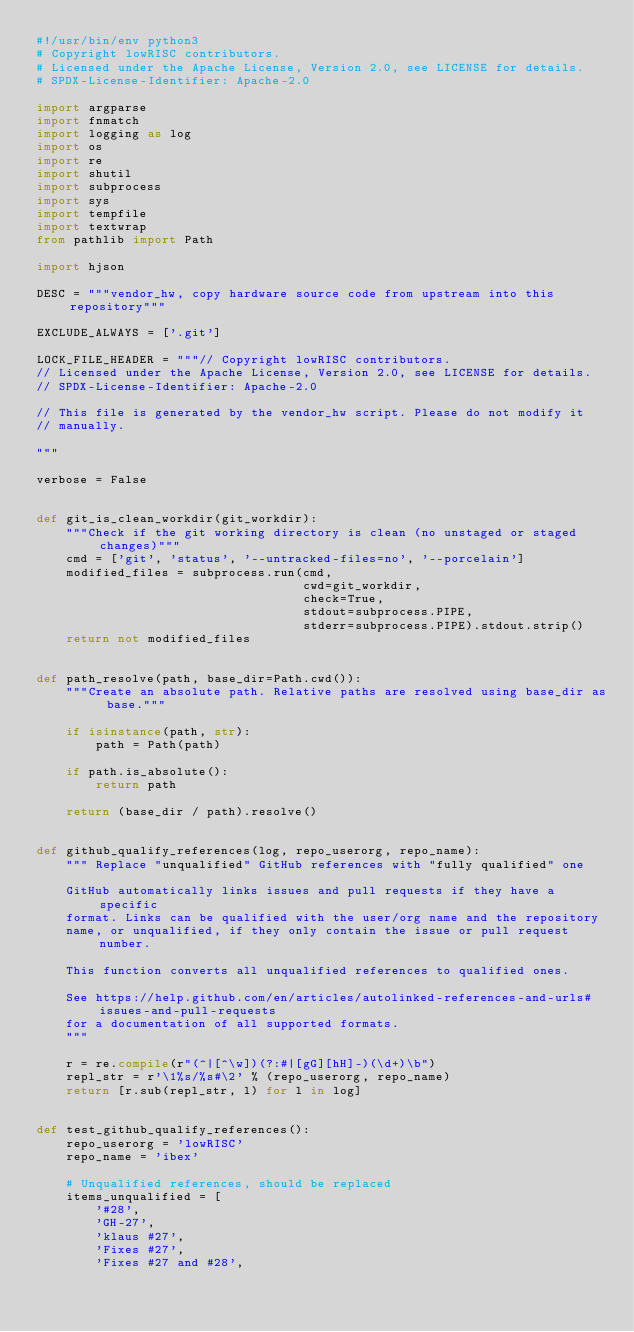<code> <loc_0><loc_0><loc_500><loc_500><_Python_>#!/usr/bin/env python3
# Copyright lowRISC contributors.
# Licensed under the Apache License, Version 2.0, see LICENSE for details.
# SPDX-License-Identifier: Apache-2.0

import argparse
import fnmatch
import logging as log
import os
import re
import shutil
import subprocess
import sys
import tempfile
import textwrap
from pathlib import Path

import hjson

DESC = """vendor_hw, copy hardware source code from upstream into this repository"""

EXCLUDE_ALWAYS = ['.git']

LOCK_FILE_HEADER = """// Copyright lowRISC contributors.
// Licensed under the Apache License, Version 2.0, see LICENSE for details.
// SPDX-License-Identifier: Apache-2.0

// This file is generated by the vendor_hw script. Please do not modify it
// manually.

"""

verbose = False


def git_is_clean_workdir(git_workdir):
    """Check if the git working directory is clean (no unstaged or staged changes)"""
    cmd = ['git', 'status', '--untracked-files=no', '--porcelain']
    modified_files = subprocess.run(cmd,
                                    cwd=git_workdir,
                                    check=True,
                                    stdout=subprocess.PIPE,
                                    stderr=subprocess.PIPE).stdout.strip()
    return not modified_files


def path_resolve(path, base_dir=Path.cwd()):
    """Create an absolute path. Relative paths are resolved using base_dir as base."""

    if isinstance(path, str):
        path = Path(path)

    if path.is_absolute():
        return path

    return (base_dir / path).resolve()


def github_qualify_references(log, repo_userorg, repo_name):
    """ Replace "unqualified" GitHub references with "fully qualified" one

    GitHub automatically links issues and pull requests if they have a specific
    format. Links can be qualified with the user/org name and the repository
    name, or unqualified, if they only contain the issue or pull request number.

    This function converts all unqualified references to qualified ones.

    See https://help.github.com/en/articles/autolinked-references-and-urls#issues-and-pull-requests
    for a documentation of all supported formats.
    """

    r = re.compile(r"(^|[^\w])(?:#|[gG][hH]-)(\d+)\b")
    repl_str = r'\1%s/%s#\2' % (repo_userorg, repo_name)
    return [r.sub(repl_str, l) for l in log]


def test_github_qualify_references():
    repo_userorg = 'lowRISC'
    repo_name = 'ibex'

    # Unqualified references, should be replaced
    items_unqualified = [
        '#28',
        'GH-27',
        'klaus #27',
        'Fixes #27',
        'Fixes #27 and #28',</code> 